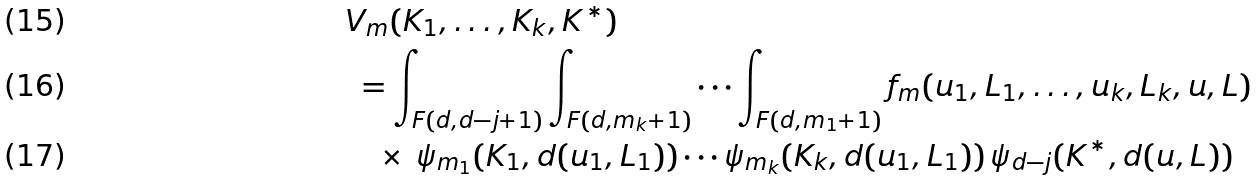Convert formula to latex. <formula><loc_0><loc_0><loc_500><loc_500>& V _ { m } ( K _ { 1 } , \dots , K _ { k } , K ^ { * } ) \\ & \ = \int _ { F ( d , d - j + 1 ) } \int _ { F ( d , m _ { k } + 1 ) } \cdots \int _ { F ( d , m _ { 1 } + 1 ) } f _ { m } ( u _ { 1 } , L _ { 1 } , \dots , u _ { k } , L _ { k } , u , L ) \\ & \quad \times \, \psi _ { m _ { 1 } } ( K _ { 1 } , d ( u _ { 1 } , L _ { 1 } ) ) \cdots \psi _ { m _ { k } } ( K _ { k } , d ( u _ { 1 } , L _ { 1 } ) ) \, \psi _ { d - j } ( K ^ { * } , d ( u , L ) )</formula> 